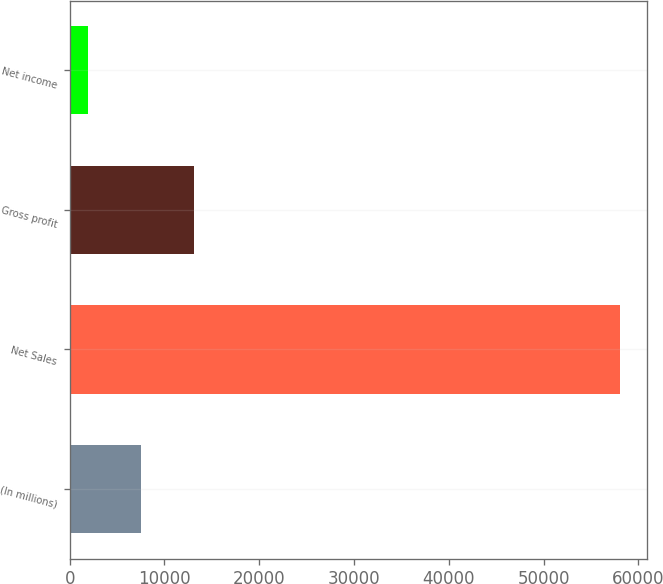<chart> <loc_0><loc_0><loc_500><loc_500><bar_chart><fcel>(In millions)<fcel>Net Sales<fcel>Gross profit<fcel>Net income<nl><fcel>7552.8<fcel>58068<fcel>13165.6<fcel>1940<nl></chart> 